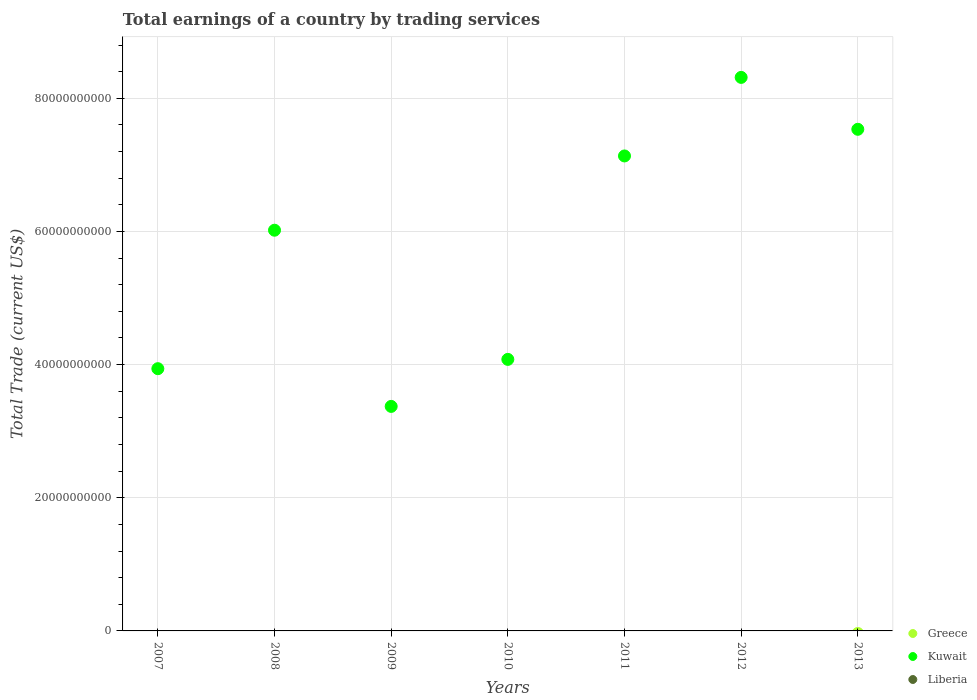What is the total earnings in Liberia in 2010?
Keep it short and to the point. 0. Across all years, what is the minimum total earnings in Kuwait?
Ensure brevity in your answer.  3.37e+1. What is the difference between the total earnings in Kuwait in 2010 and that in 2011?
Provide a succinct answer. -3.06e+1. What is the ratio of the total earnings in Kuwait in 2009 to that in 2013?
Your answer should be compact. 0.45. What is the difference between the highest and the second highest total earnings in Kuwait?
Your answer should be very brief. 7.80e+09. What is the difference between the highest and the lowest total earnings in Kuwait?
Ensure brevity in your answer.  4.94e+1. Is the sum of the total earnings in Kuwait in 2008 and 2009 greater than the maximum total earnings in Liberia across all years?
Your response must be concise. Yes. Does the total earnings in Kuwait monotonically increase over the years?
Your response must be concise. No. Is the total earnings in Greece strictly greater than the total earnings in Liberia over the years?
Make the answer very short. No. How many dotlines are there?
Your answer should be very brief. 1. How many years are there in the graph?
Ensure brevity in your answer.  7. What is the difference between two consecutive major ticks on the Y-axis?
Your answer should be compact. 2.00e+1. Does the graph contain grids?
Make the answer very short. Yes. How are the legend labels stacked?
Ensure brevity in your answer.  Vertical. What is the title of the graph?
Keep it short and to the point. Total earnings of a country by trading services. What is the label or title of the Y-axis?
Ensure brevity in your answer.  Total Trade (current US$). What is the Total Trade (current US$) of Greece in 2007?
Keep it short and to the point. 0. What is the Total Trade (current US$) in Kuwait in 2007?
Give a very brief answer. 3.94e+1. What is the Total Trade (current US$) in Kuwait in 2008?
Your answer should be very brief. 6.02e+1. What is the Total Trade (current US$) of Greece in 2009?
Your response must be concise. 0. What is the Total Trade (current US$) in Kuwait in 2009?
Provide a short and direct response. 3.37e+1. What is the Total Trade (current US$) in Kuwait in 2010?
Offer a very short reply. 4.08e+1. What is the Total Trade (current US$) in Kuwait in 2011?
Make the answer very short. 7.13e+1. What is the Total Trade (current US$) in Liberia in 2011?
Your response must be concise. 0. What is the Total Trade (current US$) in Kuwait in 2012?
Keep it short and to the point. 8.31e+1. What is the Total Trade (current US$) of Liberia in 2012?
Your answer should be compact. 0. What is the Total Trade (current US$) of Greece in 2013?
Your answer should be very brief. 0. What is the Total Trade (current US$) of Kuwait in 2013?
Your answer should be compact. 7.53e+1. Across all years, what is the maximum Total Trade (current US$) in Kuwait?
Provide a succinct answer. 8.31e+1. Across all years, what is the minimum Total Trade (current US$) in Kuwait?
Keep it short and to the point. 3.37e+1. What is the total Total Trade (current US$) in Kuwait in the graph?
Your response must be concise. 4.04e+11. What is the difference between the Total Trade (current US$) of Kuwait in 2007 and that in 2008?
Keep it short and to the point. -2.08e+1. What is the difference between the Total Trade (current US$) in Kuwait in 2007 and that in 2009?
Offer a terse response. 5.67e+09. What is the difference between the Total Trade (current US$) in Kuwait in 2007 and that in 2010?
Your answer should be very brief. -1.40e+09. What is the difference between the Total Trade (current US$) of Kuwait in 2007 and that in 2011?
Ensure brevity in your answer.  -3.20e+1. What is the difference between the Total Trade (current US$) of Kuwait in 2007 and that in 2012?
Offer a terse response. -4.38e+1. What is the difference between the Total Trade (current US$) in Kuwait in 2007 and that in 2013?
Ensure brevity in your answer.  -3.60e+1. What is the difference between the Total Trade (current US$) in Kuwait in 2008 and that in 2009?
Your answer should be compact. 2.65e+1. What is the difference between the Total Trade (current US$) of Kuwait in 2008 and that in 2010?
Ensure brevity in your answer.  1.94e+1. What is the difference between the Total Trade (current US$) of Kuwait in 2008 and that in 2011?
Give a very brief answer. -1.12e+1. What is the difference between the Total Trade (current US$) of Kuwait in 2008 and that in 2012?
Provide a succinct answer. -2.30e+1. What is the difference between the Total Trade (current US$) in Kuwait in 2008 and that in 2013?
Keep it short and to the point. -1.52e+1. What is the difference between the Total Trade (current US$) in Kuwait in 2009 and that in 2010?
Give a very brief answer. -7.06e+09. What is the difference between the Total Trade (current US$) of Kuwait in 2009 and that in 2011?
Offer a terse response. -3.76e+1. What is the difference between the Total Trade (current US$) of Kuwait in 2009 and that in 2012?
Your response must be concise. -4.94e+1. What is the difference between the Total Trade (current US$) in Kuwait in 2009 and that in 2013?
Ensure brevity in your answer.  -4.16e+1. What is the difference between the Total Trade (current US$) in Kuwait in 2010 and that in 2011?
Your answer should be compact. -3.06e+1. What is the difference between the Total Trade (current US$) in Kuwait in 2010 and that in 2012?
Offer a very short reply. -4.24e+1. What is the difference between the Total Trade (current US$) in Kuwait in 2010 and that in 2013?
Ensure brevity in your answer.  -3.46e+1. What is the difference between the Total Trade (current US$) in Kuwait in 2011 and that in 2012?
Your answer should be very brief. -1.18e+1. What is the difference between the Total Trade (current US$) of Kuwait in 2011 and that in 2013?
Give a very brief answer. -4.00e+09. What is the difference between the Total Trade (current US$) in Kuwait in 2012 and that in 2013?
Your answer should be compact. 7.80e+09. What is the average Total Trade (current US$) in Kuwait per year?
Keep it short and to the point. 5.77e+1. What is the average Total Trade (current US$) of Liberia per year?
Keep it short and to the point. 0. What is the ratio of the Total Trade (current US$) of Kuwait in 2007 to that in 2008?
Ensure brevity in your answer.  0.65. What is the ratio of the Total Trade (current US$) of Kuwait in 2007 to that in 2009?
Keep it short and to the point. 1.17. What is the ratio of the Total Trade (current US$) in Kuwait in 2007 to that in 2010?
Give a very brief answer. 0.97. What is the ratio of the Total Trade (current US$) in Kuwait in 2007 to that in 2011?
Provide a short and direct response. 0.55. What is the ratio of the Total Trade (current US$) in Kuwait in 2007 to that in 2012?
Give a very brief answer. 0.47. What is the ratio of the Total Trade (current US$) of Kuwait in 2007 to that in 2013?
Offer a very short reply. 0.52. What is the ratio of the Total Trade (current US$) of Kuwait in 2008 to that in 2009?
Provide a succinct answer. 1.78. What is the ratio of the Total Trade (current US$) in Kuwait in 2008 to that in 2010?
Make the answer very short. 1.48. What is the ratio of the Total Trade (current US$) in Kuwait in 2008 to that in 2011?
Provide a succinct answer. 0.84. What is the ratio of the Total Trade (current US$) in Kuwait in 2008 to that in 2012?
Give a very brief answer. 0.72. What is the ratio of the Total Trade (current US$) of Kuwait in 2008 to that in 2013?
Your answer should be compact. 0.8. What is the ratio of the Total Trade (current US$) in Kuwait in 2009 to that in 2010?
Your answer should be compact. 0.83. What is the ratio of the Total Trade (current US$) of Kuwait in 2009 to that in 2011?
Offer a terse response. 0.47. What is the ratio of the Total Trade (current US$) in Kuwait in 2009 to that in 2012?
Provide a succinct answer. 0.41. What is the ratio of the Total Trade (current US$) of Kuwait in 2009 to that in 2013?
Make the answer very short. 0.45. What is the ratio of the Total Trade (current US$) in Kuwait in 2010 to that in 2011?
Your answer should be very brief. 0.57. What is the ratio of the Total Trade (current US$) in Kuwait in 2010 to that in 2012?
Provide a succinct answer. 0.49. What is the ratio of the Total Trade (current US$) in Kuwait in 2010 to that in 2013?
Your answer should be compact. 0.54. What is the ratio of the Total Trade (current US$) in Kuwait in 2011 to that in 2012?
Provide a succinct answer. 0.86. What is the ratio of the Total Trade (current US$) in Kuwait in 2011 to that in 2013?
Offer a very short reply. 0.95. What is the ratio of the Total Trade (current US$) in Kuwait in 2012 to that in 2013?
Offer a terse response. 1.1. What is the difference between the highest and the second highest Total Trade (current US$) in Kuwait?
Offer a very short reply. 7.80e+09. What is the difference between the highest and the lowest Total Trade (current US$) in Kuwait?
Provide a succinct answer. 4.94e+1. 